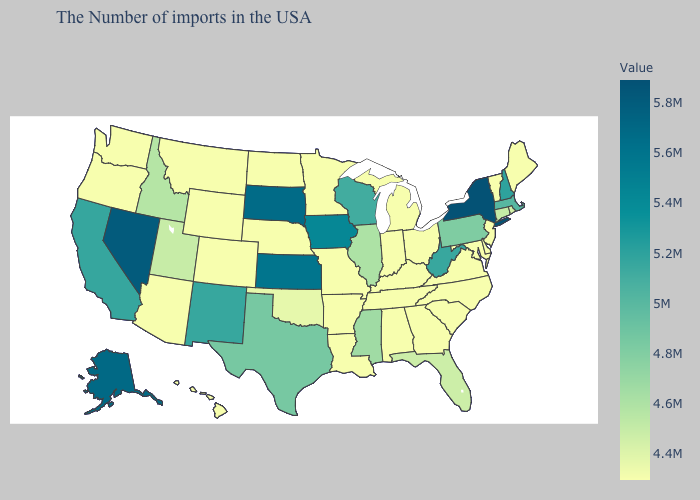Among the states that border New Hampshire , does Maine have the lowest value?
Quick response, please. Yes. Among the states that border Delaware , which have the highest value?
Concise answer only. Pennsylvania. Does the map have missing data?
Be succinct. No. Which states have the highest value in the USA?
Be succinct. New York. Does New York have the lowest value in the Northeast?
Concise answer only. No. Does New York have the highest value in the USA?
Write a very short answer. Yes. Which states have the highest value in the USA?
Short answer required. New York. 